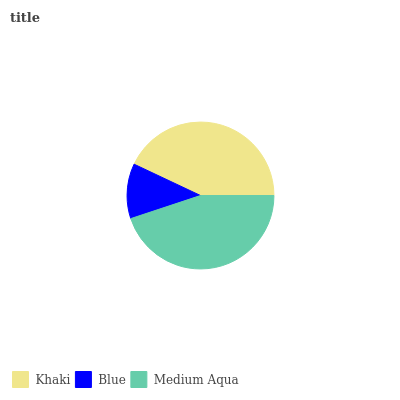Is Blue the minimum?
Answer yes or no. Yes. Is Medium Aqua the maximum?
Answer yes or no. Yes. Is Medium Aqua the minimum?
Answer yes or no. No. Is Blue the maximum?
Answer yes or no. No. Is Medium Aqua greater than Blue?
Answer yes or no. Yes. Is Blue less than Medium Aqua?
Answer yes or no. Yes. Is Blue greater than Medium Aqua?
Answer yes or no. No. Is Medium Aqua less than Blue?
Answer yes or no. No. Is Khaki the high median?
Answer yes or no. Yes. Is Khaki the low median?
Answer yes or no. Yes. Is Blue the high median?
Answer yes or no. No. Is Medium Aqua the low median?
Answer yes or no. No. 